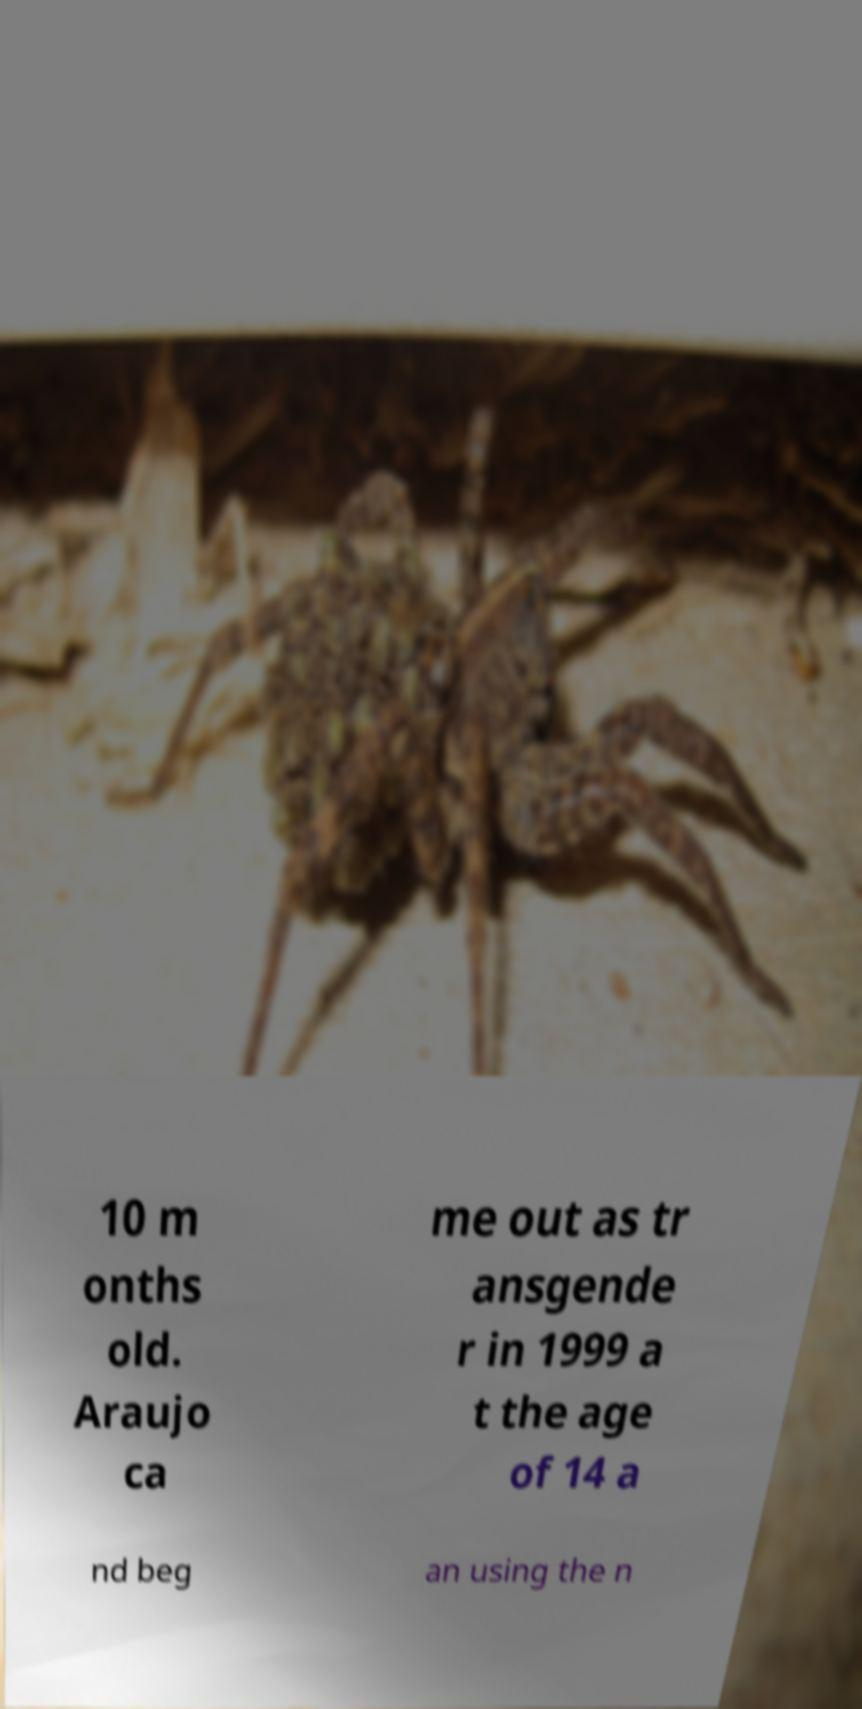Please identify and transcribe the text found in this image. 10 m onths old. Araujo ca me out as tr ansgende r in 1999 a t the age of 14 a nd beg an using the n 